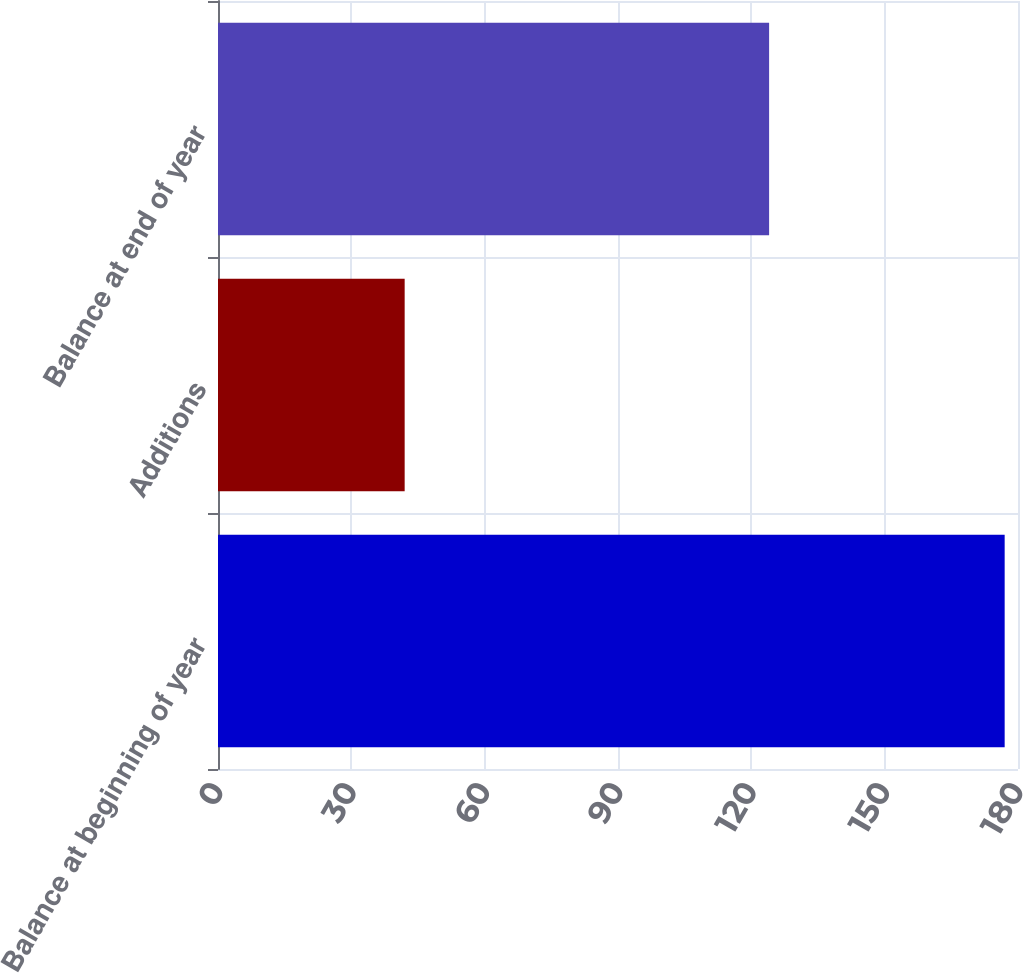<chart> <loc_0><loc_0><loc_500><loc_500><bar_chart><fcel>Balance at beginning of year<fcel>Additions<fcel>Balance at end of year<nl><fcel>177<fcel>42<fcel>124<nl></chart> 